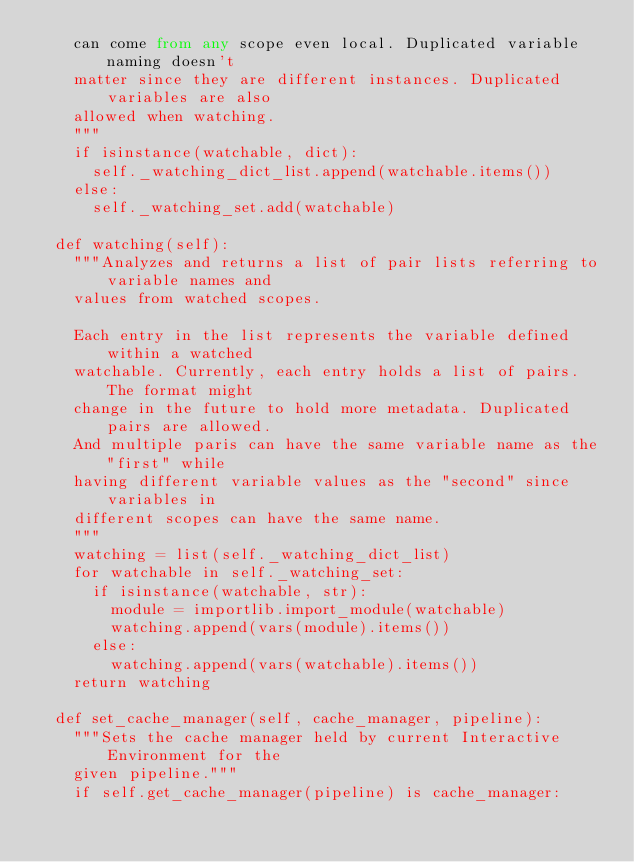Convert code to text. <code><loc_0><loc_0><loc_500><loc_500><_Python_>    can come from any scope even local. Duplicated variable naming doesn't
    matter since they are different instances. Duplicated variables are also
    allowed when watching.
    """
    if isinstance(watchable, dict):
      self._watching_dict_list.append(watchable.items())
    else:
      self._watching_set.add(watchable)

  def watching(self):
    """Analyzes and returns a list of pair lists referring to variable names and
    values from watched scopes.

    Each entry in the list represents the variable defined within a watched
    watchable. Currently, each entry holds a list of pairs. The format might
    change in the future to hold more metadata. Duplicated pairs are allowed.
    And multiple paris can have the same variable name as the "first" while
    having different variable values as the "second" since variables in
    different scopes can have the same name.
    """
    watching = list(self._watching_dict_list)
    for watchable in self._watching_set:
      if isinstance(watchable, str):
        module = importlib.import_module(watchable)
        watching.append(vars(module).items())
      else:
        watching.append(vars(watchable).items())
    return watching

  def set_cache_manager(self, cache_manager, pipeline):
    """Sets the cache manager held by current Interactive Environment for the
    given pipeline."""
    if self.get_cache_manager(pipeline) is cache_manager:</code> 